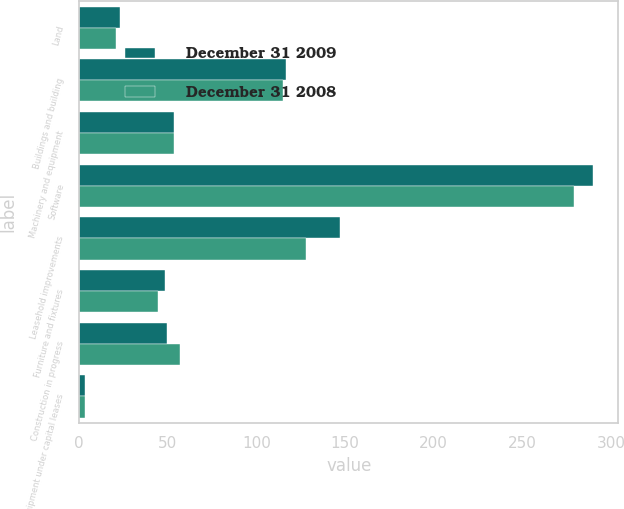<chart> <loc_0><loc_0><loc_500><loc_500><stacked_bar_chart><ecel><fcel>Land<fcel>Buildings and building<fcel>Machinery and equipment<fcel>Software<fcel>Leasehold improvements<fcel>Furniture and fixtures<fcel>Construction in progress<fcel>Equipment under capital leases<nl><fcel>December 31 2009<fcel>23.4<fcel>116.7<fcel>53.45<fcel>289.6<fcel>147<fcel>48.4<fcel>49.8<fcel>3.5<nl><fcel>December 31 2008<fcel>20.6<fcel>115.2<fcel>53.45<fcel>278.9<fcel>127.9<fcel>44.6<fcel>57.1<fcel>3.5<nl></chart> 